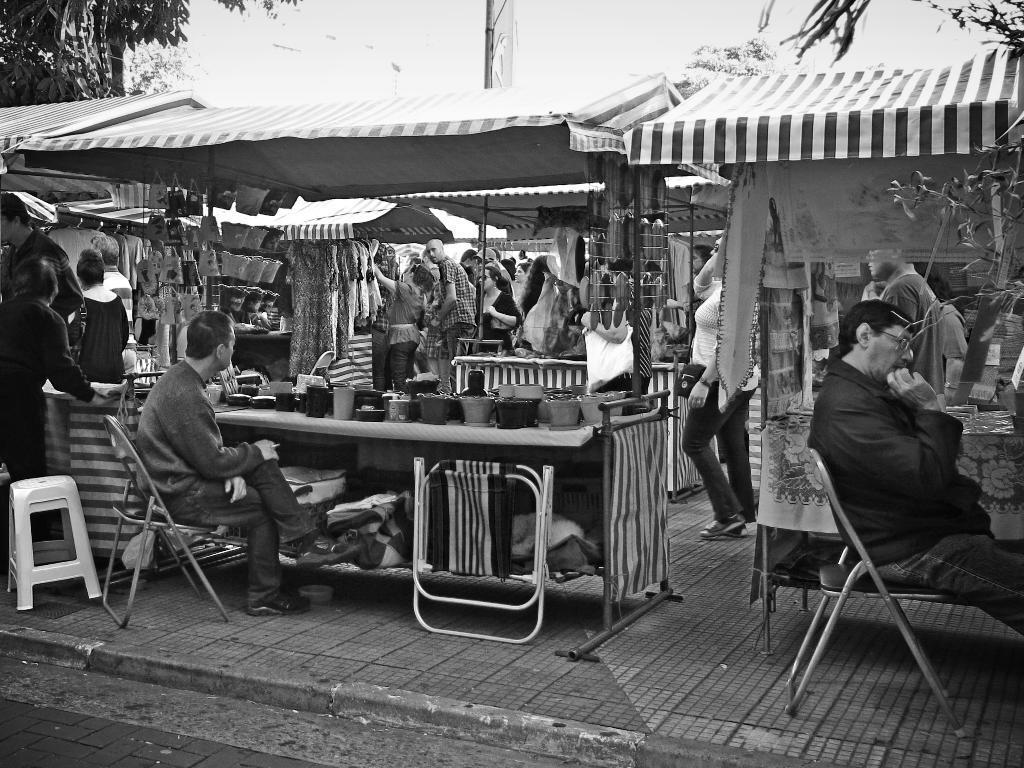How would you summarize this image in a sentence or two? In this picture there are two stalls of food and there are people those who are purchasing it, it seems to be a market place and there are umbrellas above the stalls in the image, there are trees around the area of the image and there are chairs in front of the stalls. 